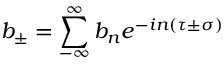<formula> <loc_0><loc_0><loc_500><loc_500>b _ { \pm } = \sum _ { - \infty } ^ { \infty } b _ { n } e ^ { - i n \left ( \tau \pm \sigma \right ) }</formula> 